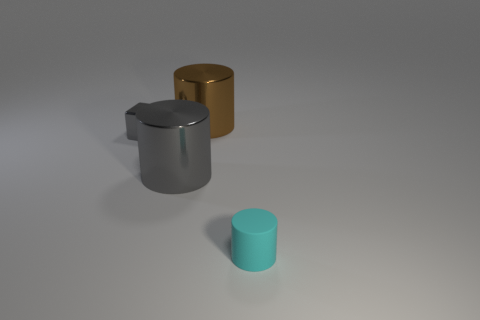What is the color of the metallic thing that is the same size as the brown shiny cylinder?
Offer a very short reply. Gray. Are there any small matte cylinders that have the same color as the small block?
Ensure brevity in your answer.  No. What is the material of the brown cylinder?
Offer a terse response. Metal. What number of small gray blocks are there?
Your answer should be compact. 1. There is a object that is right of the large brown shiny cylinder; does it have the same color as the large cylinder left of the brown shiny cylinder?
Provide a short and direct response. No. What is the size of the shiny thing that is the same color as the small metal block?
Your answer should be compact. Large. What number of other things are the same size as the brown object?
Offer a terse response. 1. What color is the tiny object left of the cyan matte object?
Offer a very short reply. Gray. Is the material of the cylinder behind the tiny gray block the same as the tiny gray cube?
Offer a very short reply. Yes. How many metal objects are both behind the big gray shiny thing and left of the big brown metal thing?
Your answer should be very brief. 1. 